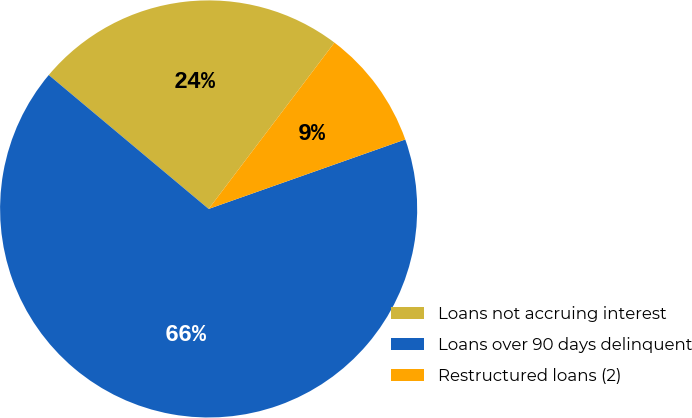Convert chart. <chart><loc_0><loc_0><loc_500><loc_500><pie_chart><fcel>Loans not accruing interest<fcel>Loans over 90 days delinquent<fcel>Restructured loans (2)<nl><fcel>24.21%<fcel>66.5%<fcel>9.29%<nl></chart> 